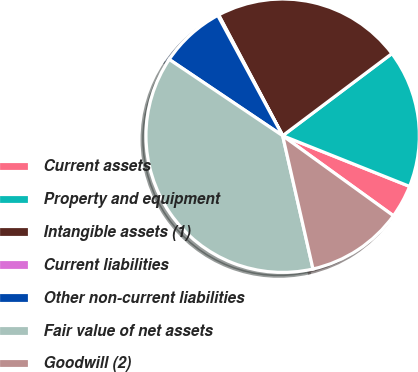<chart> <loc_0><loc_0><loc_500><loc_500><pie_chart><fcel>Current assets<fcel>Property and equipment<fcel>Intangible assets (1)<fcel>Current liabilities<fcel>Other non-current liabilities<fcel>Fair value of net assets<fcel>Goodwill (2)<nl><fcel>3.91%<fcel>16.31%<fcel>22.5%<fcel>0.12%<fcel>7.7%<fcel>37.99%<fcel>11.48%<nl></chart> 